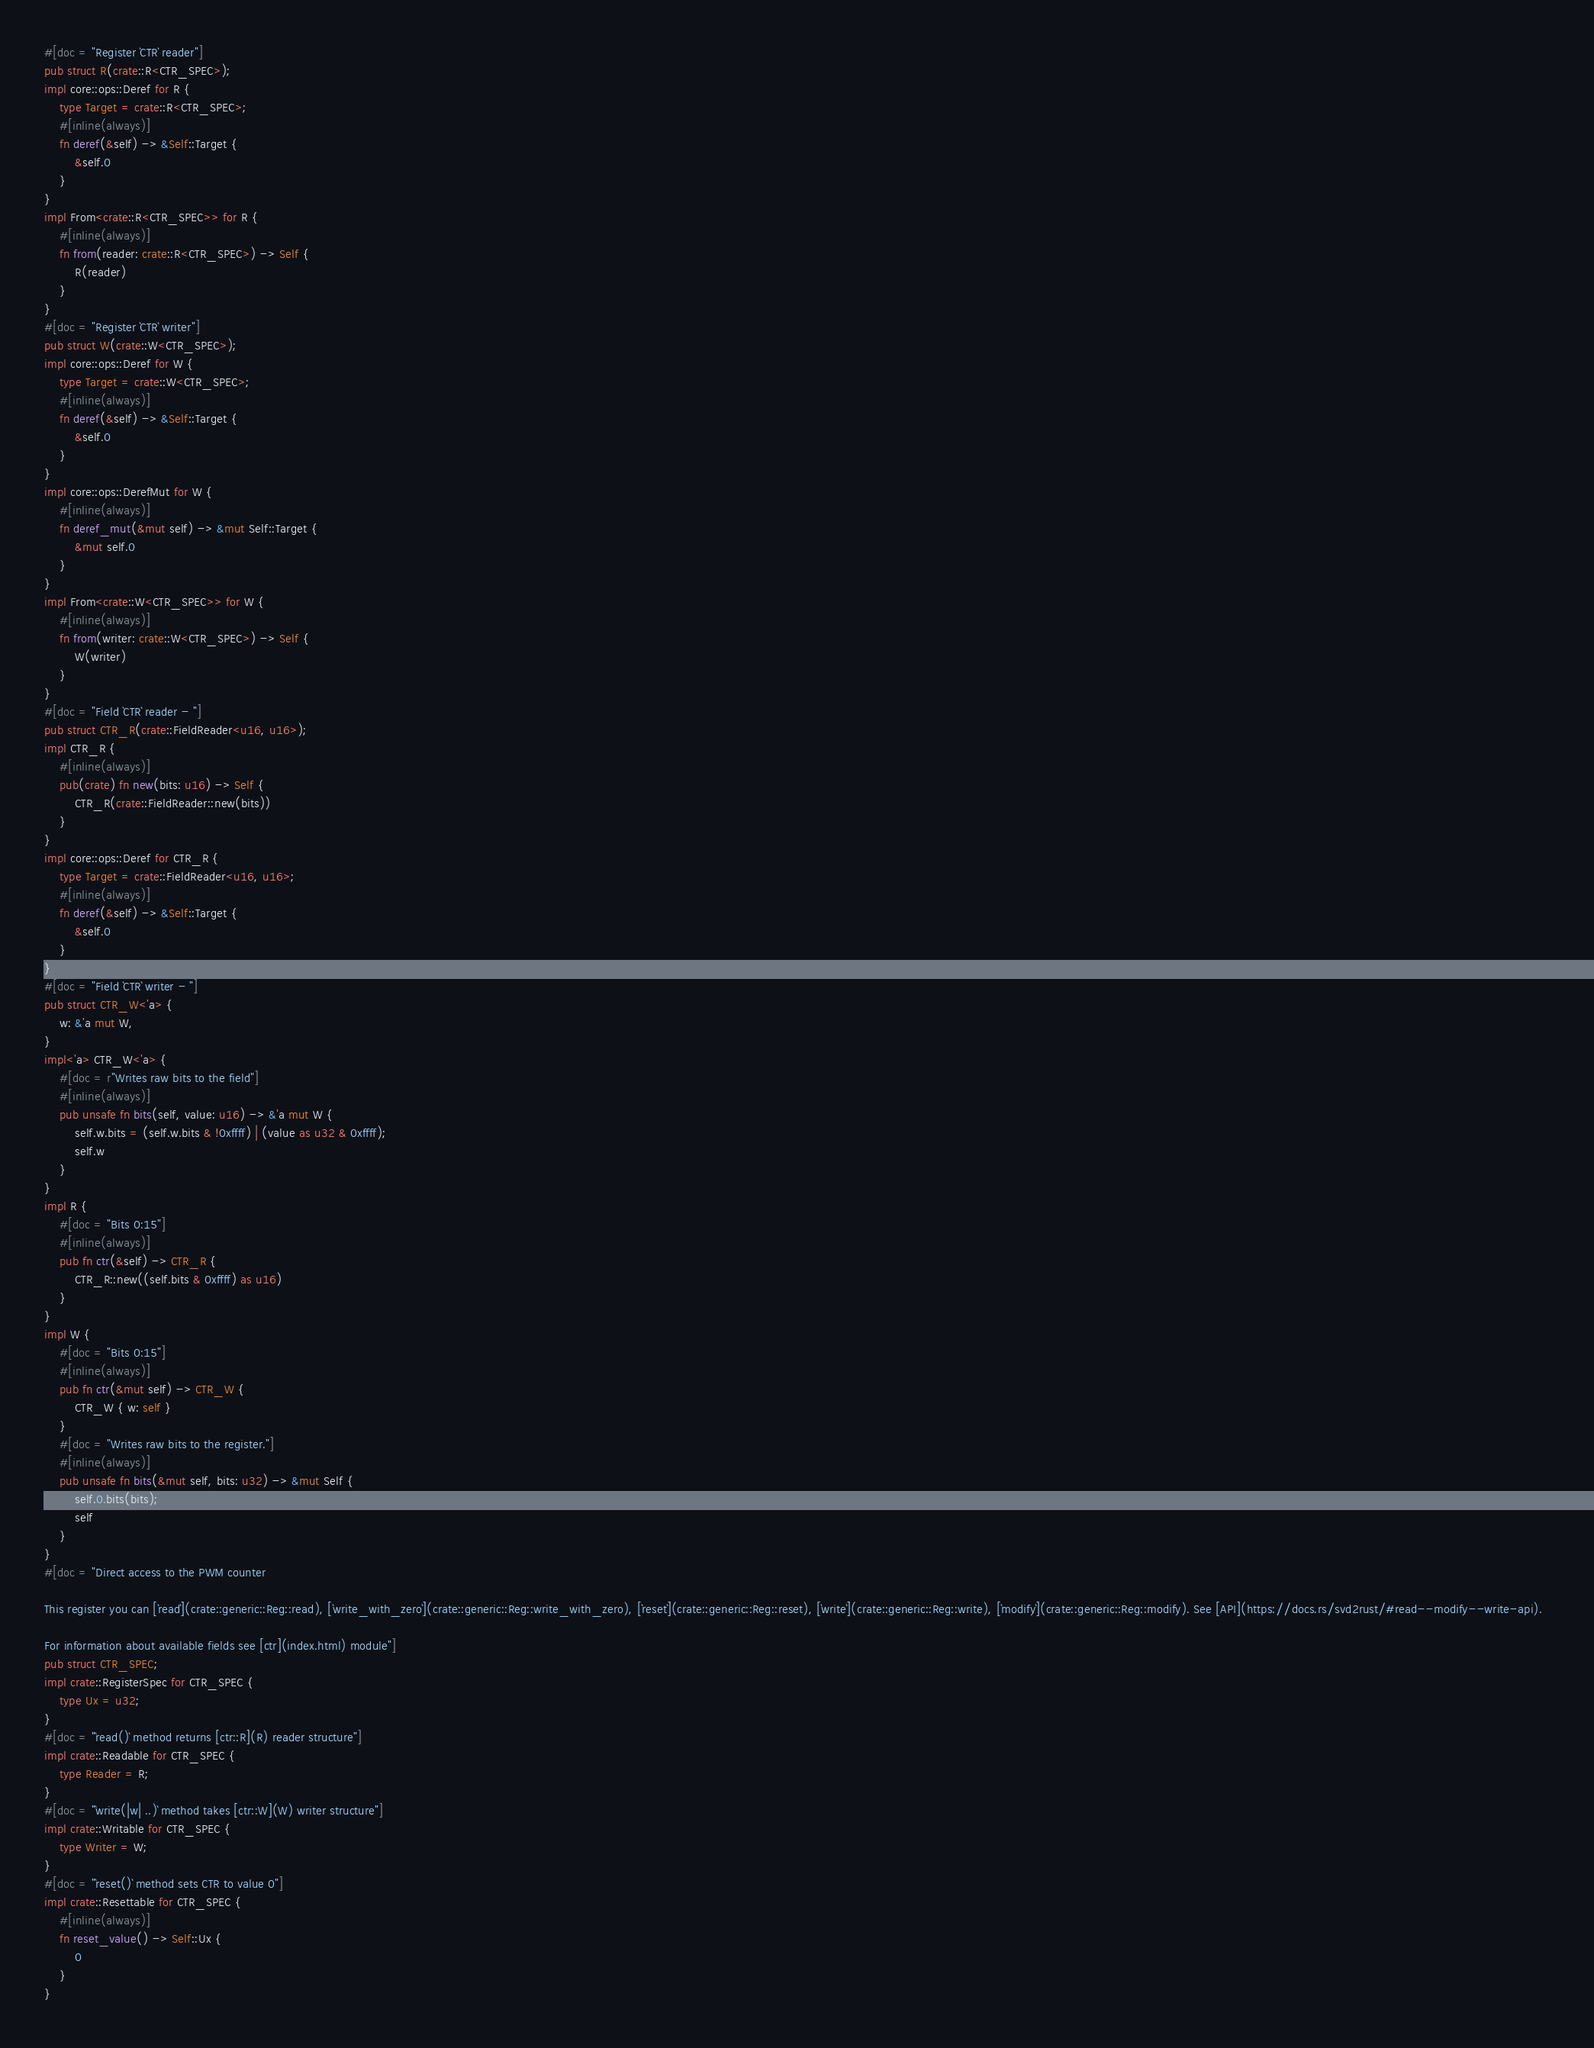Convert code to text. <code><loc_0><loc_0><loc_500><loc_500><_Rust_>#[doc = "Register `CTR` reader"]
pub struct R(crate::R<CTR_SPEC>);
impl core::ops::Deref for R {
    type Target = crate::R<CTR_SPEC>;
    #[inline(always)]
    fn deref(&self) -> &Self::Target {
        &self.0
    }
}
impl From<crate::R<CTR_SPEC>> for R {
    #[inline(always)]
    fn from(reader: crate::R<CTR_SPEC>) -> Self {
        R(reader)
    }
}
#[doc = "Register `CTR` writer"]
pub struct W(crate::W<CTR_SPEC>);
impl core::ops::Deref for W {
    type Target = crate::W<CTR_SPEC>;
    #[inline(always)]
    fn deref(&self) -> &Self::Target {
        &self.0
    }
}
impl core::ops::DerefMut for W {
    #[inline(always)]
    fn deref_mut(&mut self) -> &mut Self::Target {
        &mut self.0
    }
}
impl From<crate::W<CTR_SPEC>> for W {
    #[inline(always)]
    fn from(writer: crate::W<CTR_SPEC>) -> Self {
        W(writer)
    }
}
#[doc = "Field `CTR` reader - "]
pub struct CTR_R(crate::FieldReader<u16, u16>);
impl CTR_R {
    #[inline(always)]
    pub(crate) fn new(bits: u16) -> Self {
        CTR_R(crate::FieldReader::new(bits))
    }
}
impl core::ops::Deref for CTR_R {
    type Target = crate::FieldReader<u16, u16>;
    #[inline(always)]
    fn deref(&self) -> &Self::Target {
        &self.0
    }
}
#[doc = "Field `CTR` writer - "]
pub struct CTR_W<'a> {
    w: &'a mut W,
}
impl<'a> CTR_W<'a> {
    #[doc = r"Writes raw bits to the field"]
    #[inline(always)]
    pub unsafe fn bits(self, value: u16) -> &'a mut W {
        self.w.bits = (self.w.bits & !0xffff) | (value as u32 & 0xffff);
        self.w
    }
}
impl R {
    #[doc = "Bits 0:15"]
    #[inline(always)]
    pub fn ctr(&self) -> CTR_R {
        CTR_R::new((self.bits & 0xffff) as u16)
    }
}
impl W {
    #[doc = "Bits 0:15"]
    #[inline(always)]
    pub fn ctr(&mut self) -> CTR_W {
        CTR_W { w: self }
    }
    #[doc = "Writes raw bits to the register."]
    #[inline(always)]
    pub unsafe fn bits(&mut self, bits: u32) -> &mut Self {
        self.0.bits(bits);
        self
    }
}
#[doc = "Direct access to the PWM counter  

This register you can [`read`](crate::generic::Reg::read), [`write_with_zero`](crate::generic::Reg::write_with_zero), [`reset`](crate::generic::Reg::reset), [`write`](crate::generic::Reg::write), [`modify`](crate::generic::Reg::modify). See [API](https://docs.rs/svd2rust/#read--modify--write-api).  

For information about available fields see [ctr](index.html) module"]
pub struct CTR_SPEC;
impl crate::RegisterSpec for CTR_SPEC {
    type Ux = u32;
}
#[doc = "`read()` method returns [ctr::R](R) reader structure"]
impl crate::Readable for CTR_SPEC {
    type Reader = R;
}
#[doc = "`write(|w| ..)` method takes [ctr::W](W) writer structure"]
impl crate::Writable for CTR_SPEC {
    type Writer = W;
}
#[doc = "`reset()` method sets CTR to value 0"]
impl crate::Resettable for CTR_SPEC {
    #[inline(always)]
    fn reset_value() -> Self::Ux {
        0
    }
}
</code> 